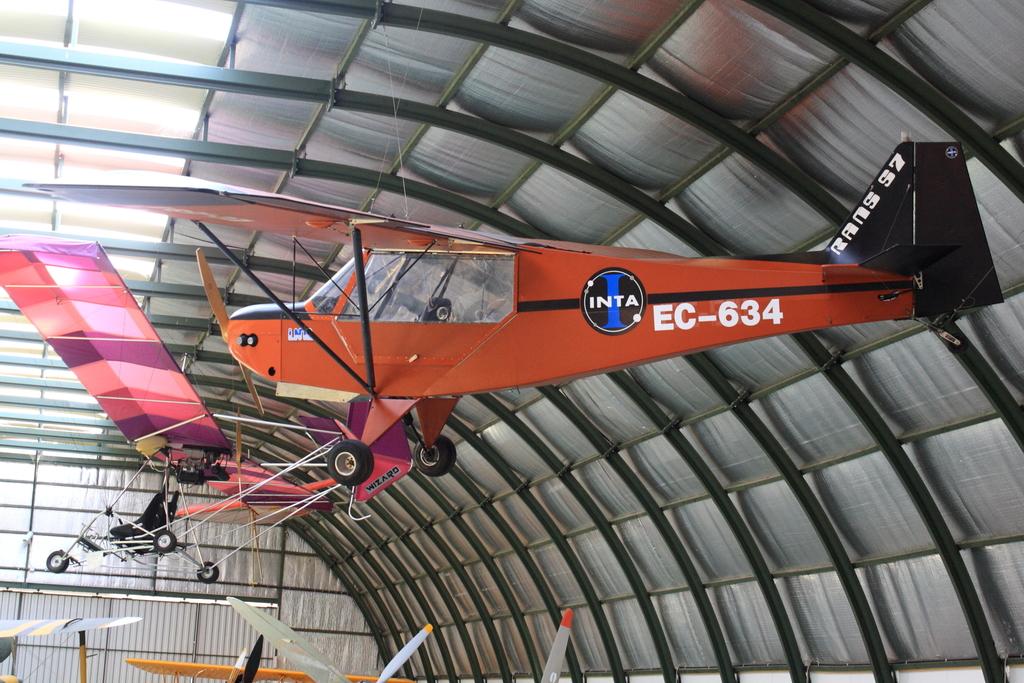What is the plane number?
Provide a short and direct response. Ec-634. What is the name of the plane?
Keep it short and to the point. Inta. 